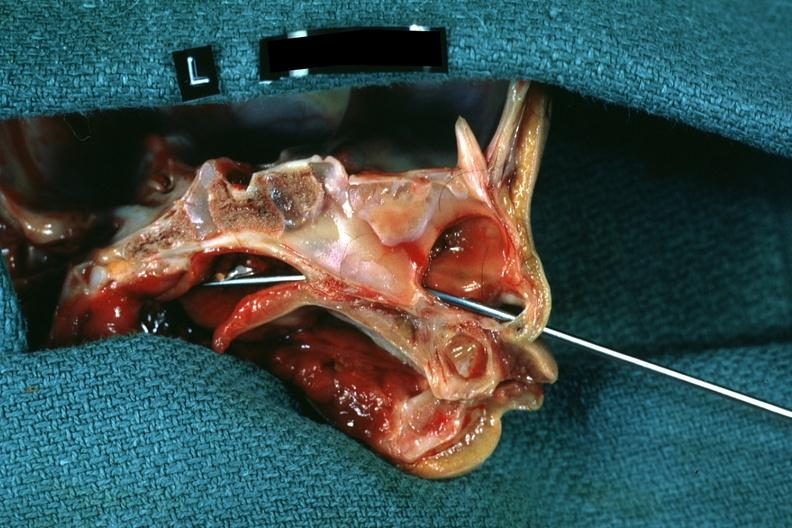does this image show hemisection of nose left side showing patency right side was not patent?
Answer the question using a single word or phrase. Yes 